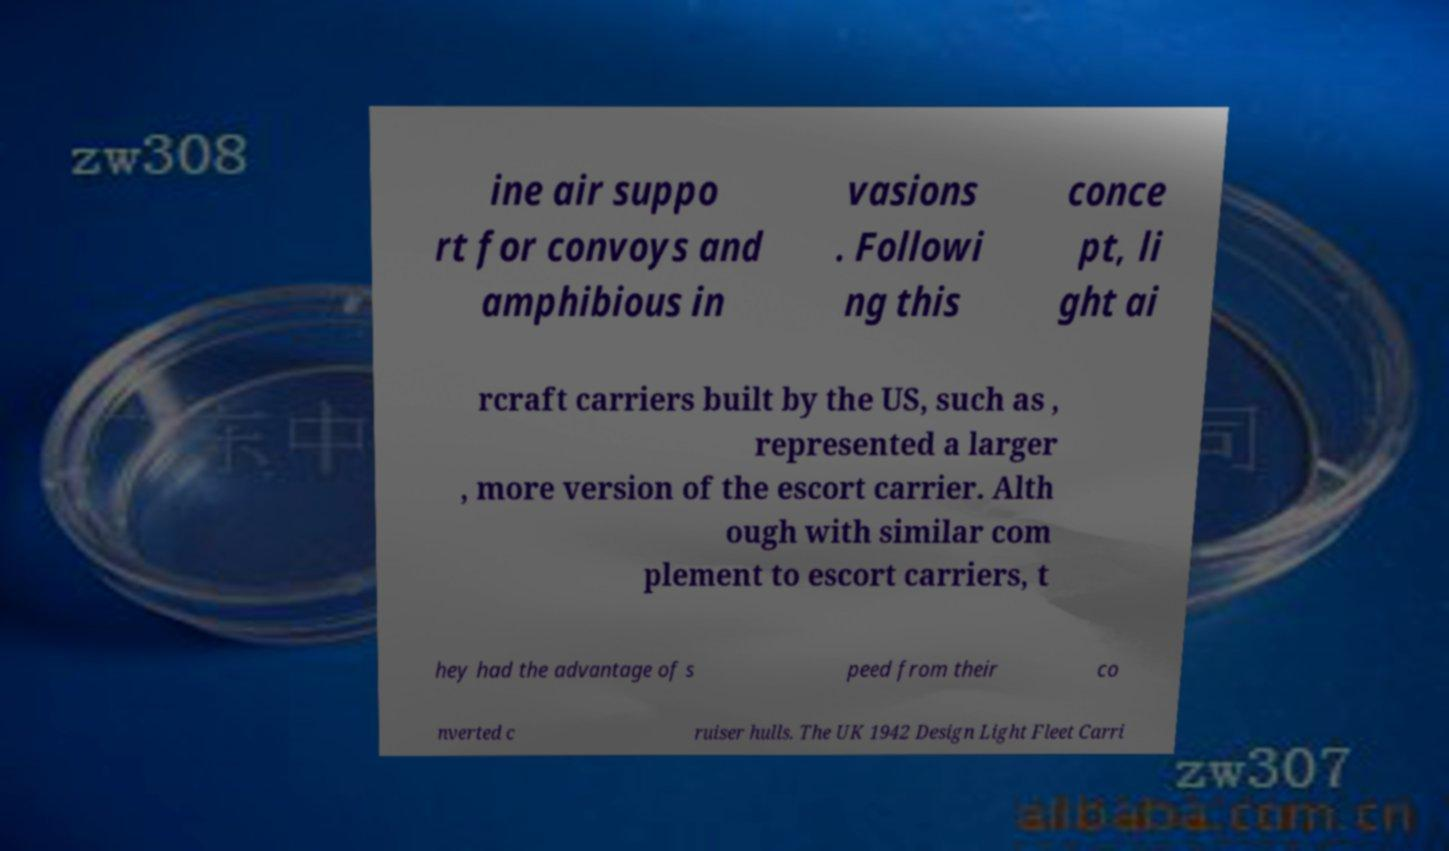There's text embedded in this image that I need extracted. Can you transcribe it verbatim? ine air suppo rt for convoys and amphibious in vasions . Followi ng this conce pt, li ght ai rcraft carriers built by the US, such as , represented a larger , more version of the escort carrier. Alth ough with similar com plement to escort carriers, t hey had the advantage of s peed from their co nverted c ruiser hulls. The UK 1942 Design Light Fleet Carri 